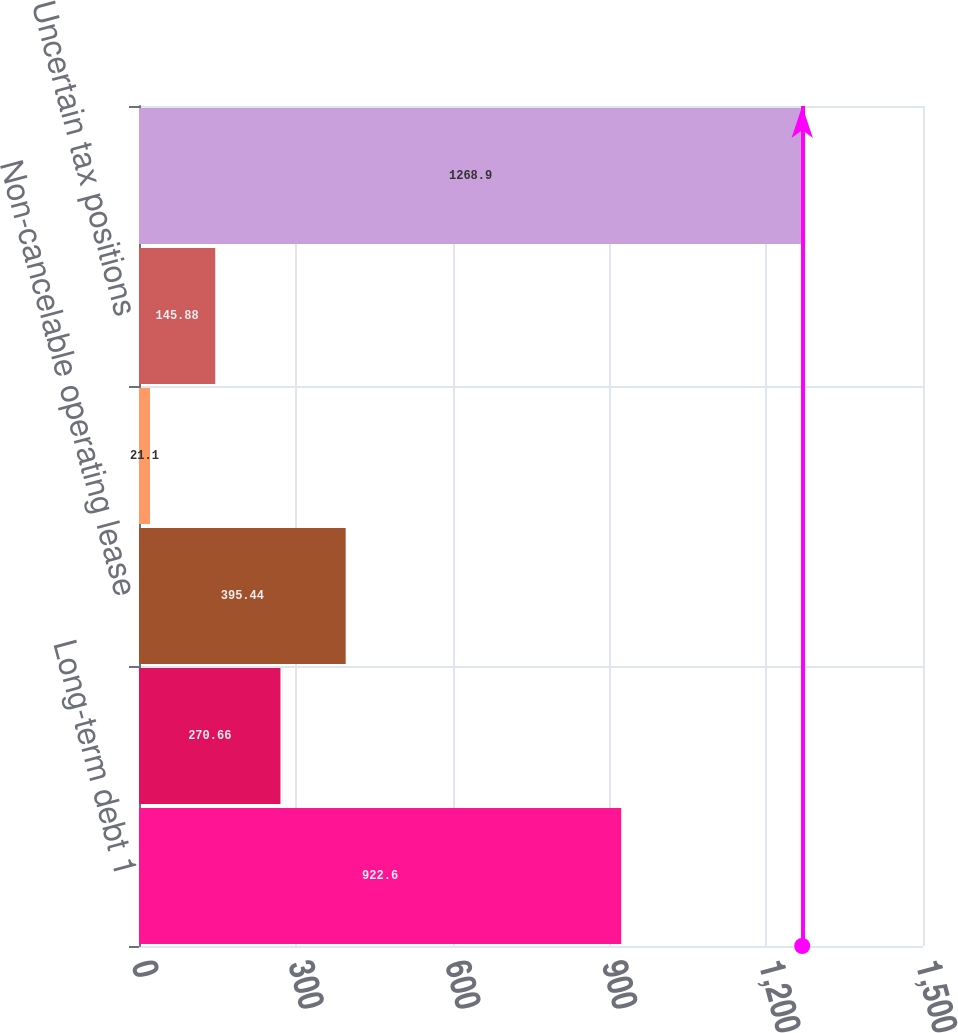Convert chart to OTSL. <chart><loc_0><loc_0><loc_500><loc_500><bar_chart><fcel>Long-term debt 1<fcel>Interest payments on long-term<fcel>Non-cancelable operating lease<fcel>Contingent acquisition<fcel>Uncertain tax positions<fcel>Total<nl><fcel>922.6<fcel>270.66<fcel>395.44<fcel>21.1<fcel>145.88<fcel>1268.9<nl></chart> 